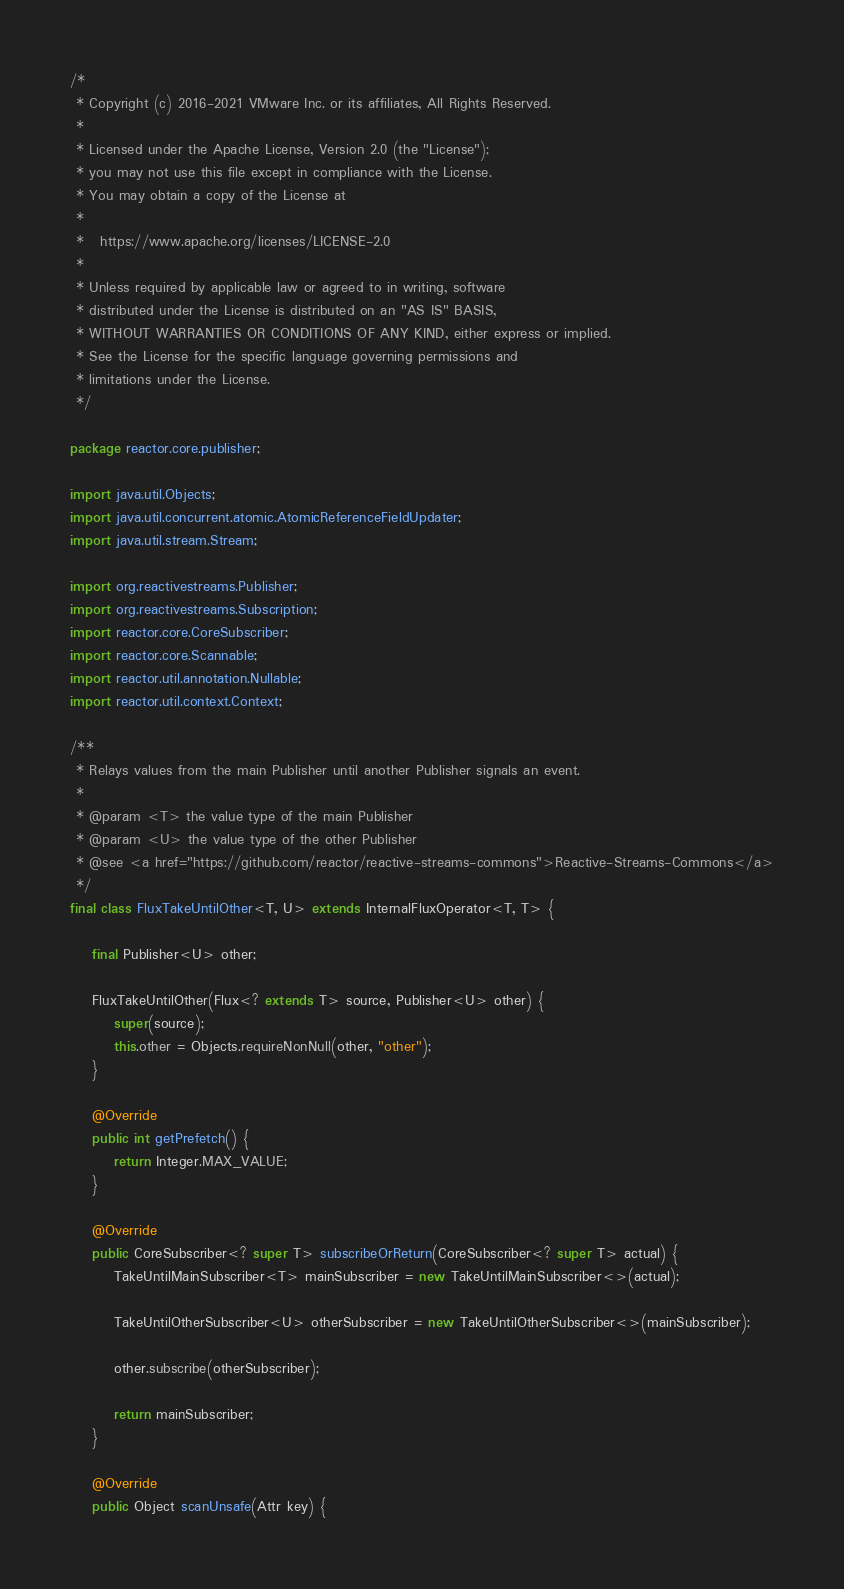Convert code to text. <code><loc_0><loc_0><loc_500><loc_500><_Java_>/*
 * Copyright (c) 2016-2021 VMware Inc. or its affiliates, All Rights Reserved.
 *
 * Licensed under the Apache License, Version 2.0 (the "License");
 * you may not use this file except in compliance with the License.
 * You may obtain a copy of the License at
 *
 *   https://www.apache.org/licenses/LICENSE-2.0
 *
 * Unless required by applicable law or agreed to in writing, software
 * distributed under the License is distributed on an "AS IS" BASIS,
 * WITHOUT WARRANTIES OR CONDITIONS OF ANY KIND, either express or implied.
 * See the License for the specific language governing permissions and
 * limitations under the License.
 */

package reactor.core.publisher;

import java.util.Objects;
import java.util.concurrent.atomic.AtomicReferenceFieldUpdater;
import java.util.stream.Stream;

import org.reactivestreams.Publisher;
import org.reactivestreams.Subscription;
import reactor.core.CoreSubscriber;
import reactor.core.Scannable;
import reactor.util.annotation.Nullable;
import reactor.util.context.Context;

/**
 * Relays values from the main Publisher until another Publisher signals an event.
 *
 * @param <T> the value type of the main Publisher
 * @param <U> the value type of the other Publisher
 * @see <a href="https://github.com/reactor/reactive-streams-commons">Reactive-Streams-Commons</a>
 */
final class FluxTakeUntilOther<T, U> extends InternalFluxOperator<T, T> {

	final Publisher<U> other;

	FluxTakeUntilOther(Flux<? extends T> source, Publisher<U> other) {
		super(source);
		this.other = Objects.requireNonNull(other, "other");
	}

	@Override
	public int getPrefetch() {
		return Integer.MAX_VALUE;
	}

	@Override
	public CoreSubscriber<? super T> subscribeOrReturn(CoreSubscriber<? super T> actual) {
		TakeUntilMainSubscriber<T> mainSubscriber = new TakeUntilMainSubscriber<>(actual);

		TakeUntilOtherSubscriber<U> otherSubscriber = new TakeUntilOtherSubscriber<>(mainSubscriber);

		other.subscribe(otherSubscriber);

		return mainSubscriber;
	}

	@Override
	public Object scanUnsafe(Attr key) {</code> 